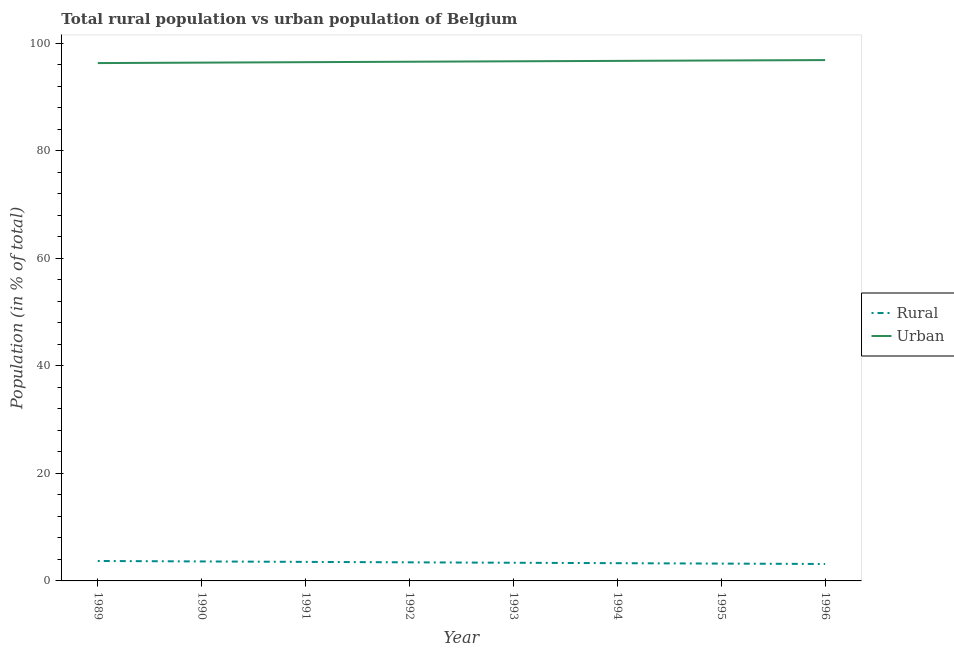Does the line corresponding to rural population intersect with the line corresponding to urban population?
Your response must be concise. No. What is the urban population in 1991?
Give a very brief answer. 96.46. Across all years, what is the maximum rural population?
Provide a short and direct response. 3.71. Across all years, what is the minimum rural population?
Offer a very short reply. 3.15. In which year was the rural population maximum?
Give a very brief answer. 1989. In which year was the rural population minimum?
Provide a succinct answer. 1996. What is the total urban population in the graph?
Your response must be concise. 772.62. What is the difference between the rural population in 1989 and that in 1996?
Keep it short and to the point. 0.56. What is the difference between the rural population in 1992 and the urban population in 1990?
Your answer should be very brief. -92.92. What is the average urban population per year?
Ensure brevity in your answer.  96.58. In the year 1989, what is the difference between the urban population and rural population?
Ensure brevity in your answer.  92.58. In how many years, is the urban population greater than 16 %?
Your response must be concise. 8. What is the ratio of the urban population in 1991 to that in 1995?
Make the answer very short. 1. Is the difference between the rural population in 1989 and 1996 greater than the difference between the urban population in 1989 and 1996?
Keep it short and to the point. Yes. What is the difference between the highest and the second highest rural population?
Provide a succinct answer. 0.08. What is the difference between the highest and the lowest rural population?
Give a very brief answer. 0.56. In how many years, is the rural population greater than the average rural population taken over all years?
Provide a succinct answer. 4. Does the rural population monotonically increase over the years?
Your answer should be very brief. No. Is the rural population strictly greater than the urban population over the years?
Your answer should be very brief. No. How many years are there in the graph?
Make the answer very short. 8. What is the title of the graph?
Give a very brief answer. Total rural population vs urban population of Belgium. What is the label or title of the X-axis?
Provide a succinct answer. Year. What is the label or title of the Y-axis?
Provide a short and direct response. Population (in % of total). What is the Population (in % of total) in Rural in 1989?
Your answer should be compact. 3.71. What is the Population (in % of total) of Urban in 1989?
Provide a succinct answer. 96.29. What is the Population (in % of total) of Rural in 1990?
Offer a terse response. 3.62. What is the Population (in % of total) of Urban in 1990?
Your answer should be very brief. 96.38. What is the Population (in % of total) of Rural in 1991?
Your answer should be very brief. 3.54. What is the Population (in % of total) in Urban in 1991?
Make the answer very short. 96.46. What is the Population (in % of total) in Rural in 1992?
Your answer should be compact. 3.46. What is the Population (in % of total) in Urban in 1992?
Ensure brevity in your answer.  96.54. What is the Population (in % of total) of Rural in 1993?
Ensure brevity in your answer.  3.38. What is the Population (in % of total) of Urban in 1993?
Ensure brevity in your answer.  96.62. What is the Population (in % of total) in Rural in 1994?
Give a very brief answer. 3.3. What is the Population (in % of total) in Urban in 1994?
Offer a very short reply. 96.7. What is the Population (in % of total) in Rural in 1995?
Make the answer very short. 3.22. What is the Population (in % of total) of Urban in 1995?
Offer a very short reply. 96.78. What is the Population (in % of total) in Rural in 1996?
Give a very brief answer. 3.15. What is the Population (in % of total) in Urban in 1996?
Offer a terse response. 96.85. Across all years, what is the maximum Population (in % of total) of Rural?
Your answer should be compact. 3.71. Across all years, what is the maximum Population (in % of total) in Urban?
Offer a terse response. 96.85. Across all years, what is the minimum Population (in % of total) in Rural?
Ensure brevity in your answer.  3.15. Across all years, what is the minimum Population (in % of total) in Urban?
Make the answer very short. 96.29. What is the total Population (in % of total) in Rural in the graph?
Keep it short and to the point. 27.38. What is the total Population (in % of total) of Urban in the graph?
Keep it short and to the point. 772.62. What is the difference between the Population (in % of total) in Rural in 1989 and that in 1990?
Ensure brevity in your answer.  0.09. What is the difference between the Population (in % of total) of Urban in 1989 and that in 1990?
Offer a very short reply. -0.09. What is the difference between the Population (in % of total) in Rural in 1989 and that in 1991?
Provide a short and direct response. 0.17. What is the difference between the Population (in % of total) in Urban in 1989 and that in 1991?
Provide a succinct answer. -0.17. What is the difference between the Population (in % of total) of Rural in 1989 and that in 1992?
Ensure brevity in your answer.  0.25. What is the difference between the Population (in % of total) of Urban in 1989 and that in 1992?
Provide a succinct answer. -0.25. What is the difference between the Population (in % of total) of Rural in 1989 and that in 1993?
Your response must be concise. 0.33. What is the difference between the Population (in % of total) in Urban in 1989 and that in 1993?
Provide a short and direct response. -0.33. What is the difference between the Population (in % of total) in Rural in 1989 and that in 1994?
Your answer should be compact. 0.41. What is the difference between the Population (in % of total) in Urban in 1989 and that in 1994?
Ensure brevity in your answer.  -0.41. What is the difference between the Population (in % of total) of Rural in 1989 and that in 1995?
Your answer should be very brief. 0.48. What is the difference between the Population (in % of total) in Urban in 1989 and that in 1995?
Your answer should be very brief. -0.48. What is the difference between the Population (in % of total) in Rural in 1989 and that in 1996?
Your answer should be very brief. 0.56. What is the difference between the Population (in % of total) in Urban in 1989 and that in 1996?
Provide a succinct answer. -0.56. What is the difference between the Population (in % of total) in Rural in 1990 and that in 1991?
Ensure brevity in your answer.  0.08. What is the difference between the Population (in % of total) of Urban in 1990 and that in 1991?
Provide a succinct answer. -0.08. What is the difference between the Population (in % of total) in Rural in 1990 and that in 1992?
Your answer should be very brief. 0.17. What is the difference between the Population (in % of total) of Urban in 1990 and that in 1992?
Keep it short and to the point. -0.17. What is the difference between the Population (in % of total) of Rural in 1990 and that in 1993?
Make the answer very short. 0.24. What is the difference between the Population (in % of total) in Urban in 1990 and that in 1993?
Give a very brief answer. -0.24. What is the difference between the Population (in % of total) of Rural in 1990 and that in 1994?
Give a very brief answer. 0.32. What is the difference between the Population (in % of total) of Urban in 1990 and that in 1994?
Your answer should be very brief. -0.32. What is the difference between the Population (in % of total) in Rural in 1990 and that in 1995?
Offer a very short reply. 0.4. What is the difference between the Population (in % of total) in Urban in 1990 and that in 1995?
Offer a very short reply. -0.4. What is the difference between the Population (in % of total) of Rural in 1990 and that in 1996?
Keep it short and to the point. 0.47. What is the difference between the Population (in % of total) of Urban in 1990 and that in 1996?
Your answer should be very brief. -0.47. What is the difference between the Population (in % of total) of Rural in 1991 and that in 1992?
Provide a short and direct response. 0.08. What is the difference between the Population (in % of total) in Urban in 1991 and that in 1992?
Your response must be concise. -0.08. What is the difference between the Population (in % of total) of Rural in 1991 and that in 1993?
Ensure brevity in your answer.  0.16. What is the difference between the Population (in % of total) in Urban in 1991 and that in 1993?
Offer a very short reply. -0.16. What is the difference between the Population (in % of total) in Rural in 1991 and that in 1994?
Keep it short and to the point. 0.24. What is the difference between the Population (in % of total) of Urban in 1991 and that in 1994?
Your response must be concise. -0.24. What is the difference between the Population (in % of total) in Rural in 1991 and that in 1995?
Provide a succinct answer. 0.32. What is the difference between the Population (in % of total) of Urban in 1991 and that in 1995?
Make the answer very short. -0.32. What is the difference between the Population (in % of total) of Rural in 1991 and that in 1996?
Make the answer very short. 0.39. What is the difference between the Population (in % of total) in Urban in 1991 and that in 1996?
Make the answer very short. -0.39. What is the difference between the Population (in % of total) of Urban in 1992 and that in 1993?
Offer a very short reply. -0.08. What is the difference between the Population (in % of total) of Rural in 1992 and that in 1994?
Provide a short and direct response. 0.16. What is the difference between the Population (in % of total) in Urban in 1992 and that in 1994?
Ensure brevity in your answer.  -0.16. What is the difference between the Population (in % of total) in Rural in 1992 and that in 1995?
Provide a succinct answer. 0.23. What is the difference between the Population (in % of total) of Urban in 1992 and that in 1995?
Provide a short and direct response. -0.23. What is the difference between the Population (in % of total) of Rural in 1992 and that in 1996?
Your answer should be very brief. 0.31. What is the difference between the Population (in % of total) of Urban in 1992 and that in 1996?
Offer a very short reply. -0.31. What is the difference between the Population (in % of total) in Rural in 1993 and that in 1994?
Provide a short and direct response. 0.08. What is the difference between the Population (in % of total) in Urban in 1993 and that in 1994?
Your answer should be compact. -0.08. What is the difference between the Population (in % of total) of Rural in 1993 and that in 1995?
Offer a very short reply. 0.15. What is the difference between the Population (in % of total) in Urban in 1993 and that in 1995?
Provide a short and direct response. -0.15. What is the difference between the Population (in % of total) in Rural in 1993 and that in 1996?
Your answer should be compact. 0.23. What is the difference between the Population (in % of total) in Urban in 1993 and that in 1996?
Make the answer very short. -0.23. What is the difference between the Population (in % of total) in Rural in 1994 and that in 1995?
Ensure brevity in your answer.  0.08. What is the difference between the Population (in % of total) of Urban in 1994 and that in 1995?
Your answer should be very brief. -0.08. What is the difference between the Population (in % of total) in Rural in 1994 and that in 1996?
Your response must be concise. 0.15. What is the difference between the Population (in % of total) in Urban in 1994 and that in 1996?
Keep it short and to the point. -0.15. What is the difference between the Population (in % of total) in Rural in 1995 and that in 1996?
Offer a very short reply. 0.07. What is the difference between the Population (in % of total) of Urban in 1995 and that in 1996?
Offer a very short reply. -0.07. What is the difference between the Population (in % of total) of Rural in 1989 and the Population (in % of total) of Urban in 1990?
Offer a terse response. -92.67. What is the difference between the Population (in % of total) of Rural in 1989 and the Population (in % of total) of Urban in 1991?
Make the answer very short. -92.75. What is the difference between the Population (in % of total) of Rural in 1989 and the Population (in % of total) of Urban in 1992?
Offer a terse response. -92.83. What is the difference between the Population (in % of total) of Rural in 1989 and the Population (in % of total) of Urban in 1993?
Offer a terse response. -92.91. What is the difference between the Population (in % of total) in Rural in 1989 and the Population (in % of total) in Urban in 1994?
Offer a terse response. -92.99. What is the difference between the Population (in % of total) of Rural in 1989 and the Population (in % of total) of Urban in 1995?
Make the answer very short. -93.07. What is the difference between the Population (in % of total) in Rural in 1989 and the Population (in % of total) in Urban in 1996?
Your answer should be very brief. -93.14. What is the difference between the Population (in % of total) in Rural in 1990 and the Population (in % of total) in Urban in 1991?
Provide a succinct answer. -92.84. What is the difference between the Population (in % of total) in Rural in 1990 and the Population (in % of total) in Urban in 1992?
Ensure brevity in your answer.  -92.92. What is the difference between the Population (in % of total) in Rural in 1990 and the Population (in % of total) in Urban in 1993?
Offer a terse response. -93. What is the difference between the Population (in % of total) in Rural in 1990 and the Population (in % of total) in Urban in 1994?
Offer a very short reply. -93.08. What is the difference between the Population (in % of total) in Rural in 1990 and the Population (in % of total) in Urban in 1995?
Make the answer very short. -93.15. What is the difference between the Population (in % of total) in Rural in 1990 and the Population (in % of total) in Urban in 1996?
Your answer should be compact. -93.23. What is the difference between the Population (in % of total) of Rural in 1991 and the Population (in % of total) of Urban in 1992?
Offer a terse response. -93. What is the difference between the Population (in % of total) of Rural in 1991 and the Population (in % of total) of Urban in 1993?
Your answer should be very brief. -93.08. What is the difference between the Population (in % of total) in Rural in 1991 and the Population (in % of total) in Urban in 1994?
Offer a terse response. -93.16. What is the difference between the Population (in % of total) of Rural in 1991 and the Population (in % of total) of Urban in 1995?
Your response must be concise. -93.24. What is the difference between the Population (in % of total) in Rural in 1991 and the Population (in % of total) in Urban in 1996?
Ensure brevity in your answer.  -93.31. What is the difference between the Population (in % of total) in Rural in 1992 and the Population (in % of total) in Urban in 1993?
Offer a terse response. -93.16. What is the difference between the Population (in % of total) of Rural in 1992 and the Population (in % of total) of Urban in 1994?
Your response must be concise. -93.24. What is the difference between the Population (in % of total) of Rural in 1992 and the Population (in % of total) of Urban in 1995?
Offer a terse response. -93.32. What is the difference between the Population (in % of total) of Rural in 1992 and the Population (in % of total) of Urban in 1996?
Offer a terse response. -93.39. What is the difference between the Population (in % of total) in Rural in 1993 and the Population (in % of total) in Urban in 1994?
Your answer should be compact. -93.32. What is the difference between the Population (in % of total) of Rural in 1993 and the Population (in % of total) of Urban in 1995?
Provide a short and direct response. -93.4. What is the difference between the Population (in % of total) of Rural in 1993 and the Population (in % of total) of Urban in 1996?
Offer a terse response. -93.47. What is the difference between the Population (in % of total) in Rural in 1994 and the Population (in % of total) in Urban in 1995?
Make the answer very short. -93.48. What is the difference between the Population (in % of total) in Rural in 1994 and the Population (in % of total) in Urban in 1996?
Your answer should be very brief. -93.55. What is the difference between the Population (in % of total) in Rural in 1995 and the Population (in % of total) in Urban in 1996?
Your answer should be very brief. -93.63. What is the average Population (in % of total) in Rural per year?
Provide a short and direct response. 3.42. What is the average Population (in % of total) in Urban per year?
Give a very brief answer. 96.58. In the year 1989, what is the difference between the Population (in % of total) in Rural and Population (in % of total) in Urban?
Make the answer very short. -92.58. In the year 1990, what is the difference between the Population (in % of total) of Rural and Population (in % of total) of Urban?
Offer a terse response. -92.75. In the year 1991, what is the difference between the Population (in % of total) of Rural and Population (in % of total) of Urban?
Your answer should be very brief. -92.92. In the year 1992, what is the difference between the Population (in % of total) of Rural and Population (in % of total) of Urban?
Provide a succinct answer. -93.08. In the year 1993, what is the difference between the Population (in % of total) in Rural and Population (in % of total) in Urban?
Keep it short and to the point. -93.24. In the year 1994, what is the difference between the Population (in % of total) in Rural and Population (in % of total) in Urban?
Give a very brief answer. -93.4. In the year 1995, what is the difference between the Population (in % of total) in Rural and Population (in % of total) in Urban?
Your response must be concise. -93.55. In the year 1996, what is the difference between the Population (in % of total) of Rural and Population (in % of total) of Urban?
Offer a very short reply. -93.7. What is the ratio of the Population (in % of total) of Rural in 1989 to that in 1990?
Offer a terse response. 1.02. What is the ratio of the Population (in % of total) of Urban in 1989 to that in 1990?
Provide a short and direct response. 1. What is the ratio of the Population (in % of total) of Rural in 1989 to that in 1991?
Your answer should be very brief. 1.05. What is the ratio of the Population (in % of total) of Rural in 1989 to that in 1992?
Make the answer very short. 1.07. What is the ratio of the Population (in % of total) of Rural in 1989 to that in 1993?
Offer a terse response. 1.1. What is the ratio of the Population (in % of total) of Rural in 1989 to that in 1994?
Offer a terse response. 1.12. What is the ratio of the Population (in % of total) of Rural in 1989 to that in 1995?
Make the answer very short. 1.15. What is the ratio of the Population (in % of total) of Rural in 1989 to that in 1996?
Provide a succinct answer. 1.18. What is the ratio of the Population (in % of total) of Rural in 1990 to that in 1991?
Provide a succinct answer. 1.02. What is the ratio of the Population (in % of total) in Urban in 1990 to that in 1991?
Offer a very short reply. 1. What is the ratio of the Population (in % of total) in Rural in 1990 to that in 1992?
Your response must be concise. 1.05. What is the ratio of the Population (in % of total) in Rural in 1990 to that in 1993?
Keep it short and to the point. 1.07. What is the ratio of the Population (in % of total) of Urban in 1990 to that in 1993?
Your answer should be compact. 1. What is the ratio of the Population (in % of total) in Rural in 1990 to that in 1994?
Give a very brief answer. 1.1. What is the ratio of the Population (in % of total) of Rural in 1990 to that in 1995?
Your answer should be compact. 1.12. What is the ratio of the Population (in % of total) in Rural in 1990 to that in 1996?
Your answer should be very brief. 1.15. What is the ratio of the Population (in % of total) in Urban in 1990 to that in 1996?
Make the answer very short. 1. What is the ratio of the Population (in % of total) in Rural in 1991 to that in 1992?
Make the answer very short. 1.02. What is the ratio of the Population (in % of total) in Rural in 1991 to that in 1993?
Your answer should be very brief. 1.05. What is the ratio of the Population (in % of total) in Rural in 1991 to that in 1994?
Your answer should be very brief. 1.07. What is the ratio of the Population (in % of total) in Urban in 1991 to that in 1994?
Ensure brevity in your answer.  1. What is the ratio of the Population (in % of total) of Rural in 1991 to that in 1995?
Offer a terse response. 1.1. What is the ratio of the Population (in % of total) in Urban in 1991 to that in 1995?
Your response must be concise. 1. What is the ratio of the Population (in % of total) in Rural in 1991 to that in 1996?
Make the answer very short. 1.12. What is the ratio of the Population (in % of total) of Rural in 1992 to that in 1993?
Ensure brevity in your answer.  1.02. What is the ratio of the Population (in % of total) in Rural in 1992 to that in 1994?
Make the answer very short. 1.05. What is the ratio of the Population (in % of total) in Rural in 1992 to that in 1995?
Offer a terse response. 1.07. What is the ratio of the Population (in % of total) in Rural in 1992 to that in 1996?
Keep it short and to the point. 1.1. What is the ratio of the Population (in % of total) of Rural in 1993 to that in 1994?
Offer a very short reply. 1.02. What is the ratio of the Population (in % of total) in Urban in 1993 to that in 1994?
Your answer should be compact. 1. What is the ratio of the Population (in % of total) of Rural in 1993 to that in 1995?
Make the answer very short. 1.05. What is the ratio of the Population (in % of total) in Rural in 1993 to that in 1996?
Offer a very short reply. 1.07. What is the ratio of the Population (in % of total) of Urban in 1993 to that in 1996?
Offer a very short reply. 1. What is the ratio of the Population (in % of total) in Rural in 1994 to that in 1995?
Provide a short and direct response. 1.02. What is the ratio of the Population (in % of total) of Urban in 1994 to that in 1995?
Offer a very short reply. 1. What is the ratio of the Population (in % of total) of Rural in 1994 to that in 1996?
Offer a very short reply. 1.05. What is the ratio of the Population (in % of total) in Urban in 1994 to that in 1996?
Keep it short and to the point. 1. What is the ratio of the Population (in % of total) in Rural in 1995 to that in 1996?
Ensure brevity in your answer.  1.02. What is the ratio of the Population (in % of total) of Urban in 1995 to that in 1996?
Provide a succinct answer. 1. What is the difference between the highest and the second highest Population (in % of total) in Rural?
Your answer should be very brief. 0.09. What is the difference between the highest and the second highest Population (in % of total) of Urban?
Offer a terse response. 0.07. What is the difference between the highest and the lowest Population (in % of total) of Rural?
Provide a succinct answer. 0.56. What is the difference between the highest and the lowest Population (in % of total) in Urban?
Provide a succinct answer. 0.56. 